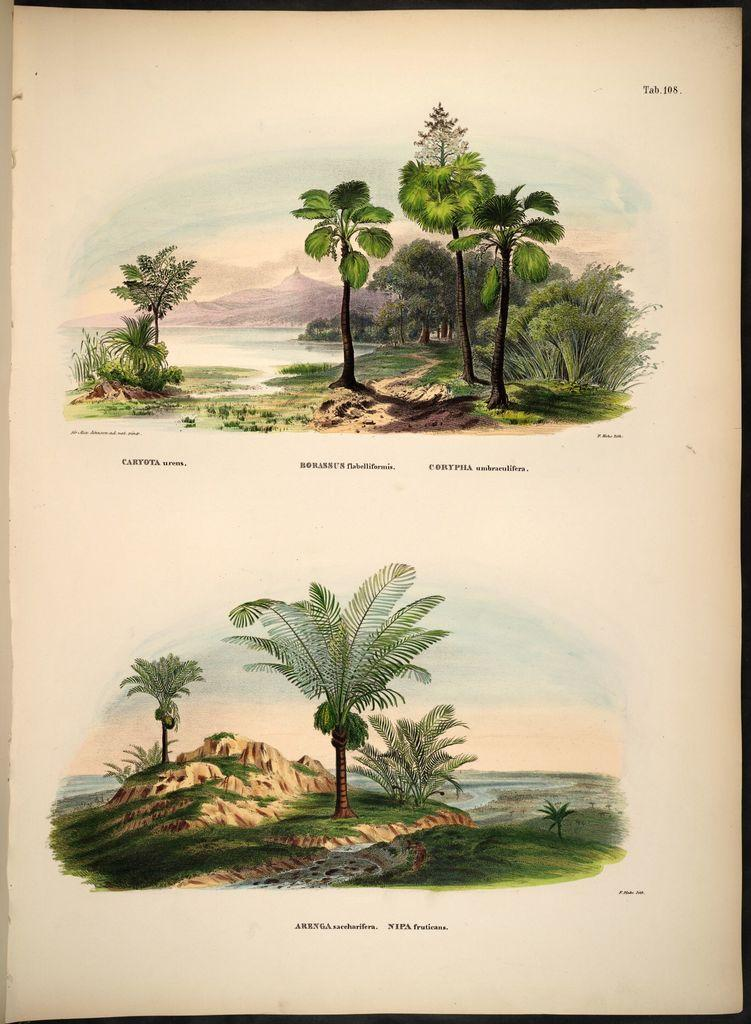What type of natural elements are depicted in the paintings on the page? The paintings on the page contain paintings of trees, a river, plants, and grasses. How many paintings are there on the page? There are two paintings on the page. Is there any text on the page? Yes, there is writing on the page. What type of scale is used to weigh the vessel in the painting? There is no scale or vessel present in the painting; it contains paintings of natural elements such as trees, a river, plants, and grasses. What type of ornament is hanging from the tree in the painting? There is no ornament hanging from the tree in the painting; it only depicts the tree itself. 